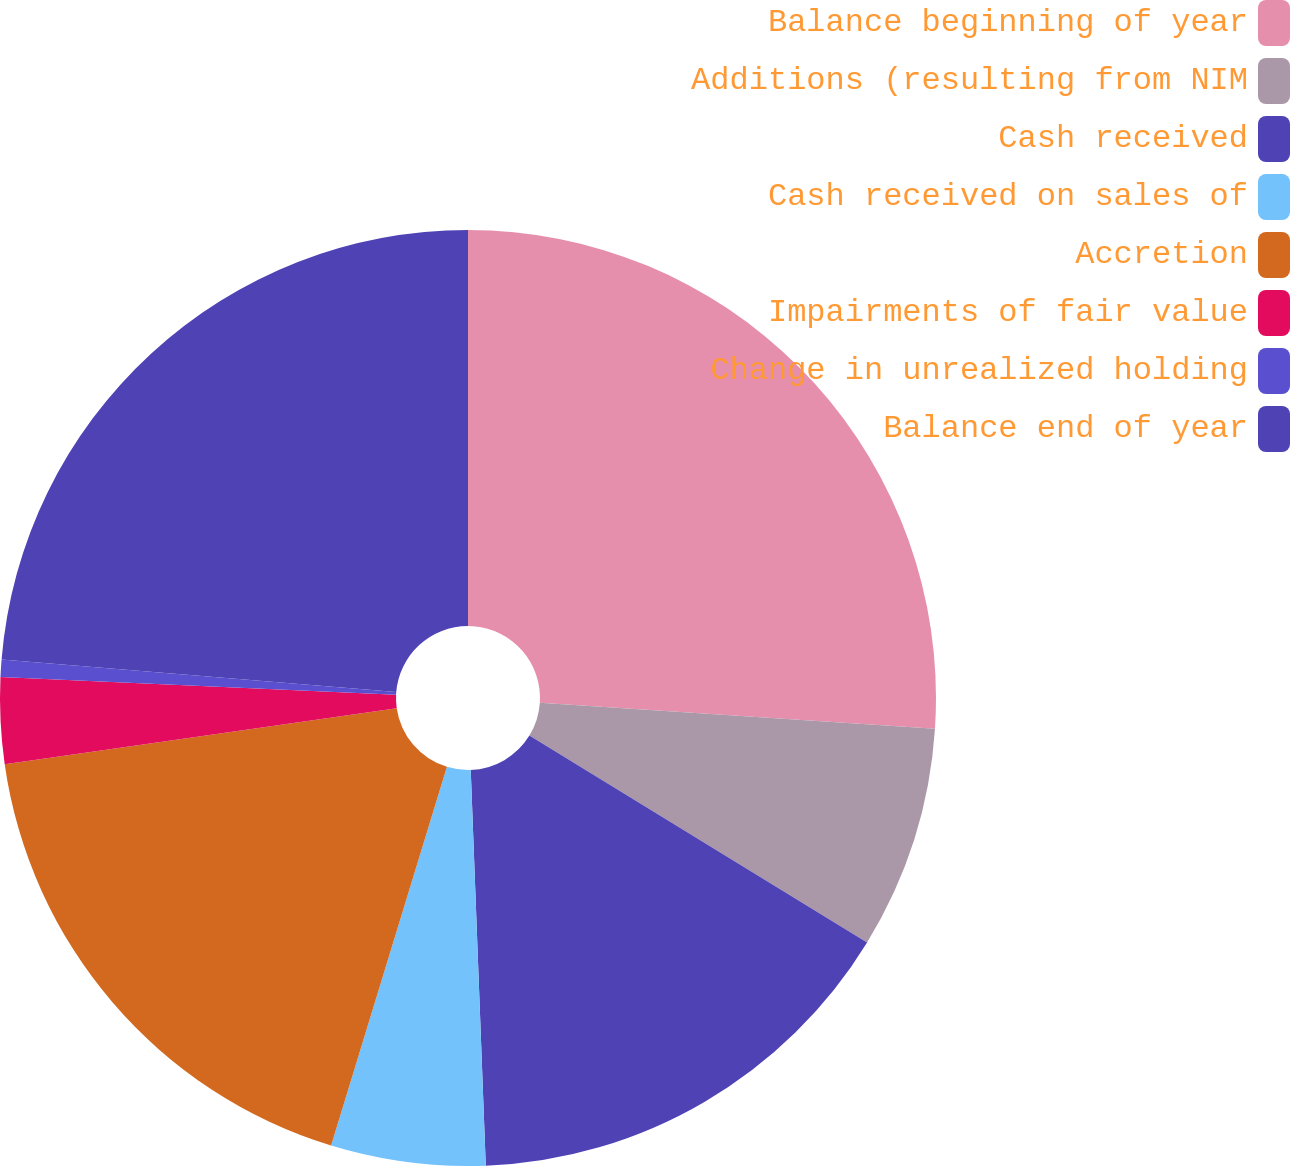<chart> <loc_0><loc_0><loc_500><loc_500><pie_chart><fcel>Balance beginning of year<fcel>Additions (resulting from NIM<fcel>Cash received<fcel>Cash received on sales of<fcel>Accretion<fcel>Impairments of fair value<fcel>Change in unrealized holding<fcel>Balance end of year<nl><fcel>26.05%<fcel>7.7%<fcel>15.65%<fcel>5.33%<fcel>18.02%<fcel>2.97%<fcel>0.6%<fcel>23.69%<nl></chart> 